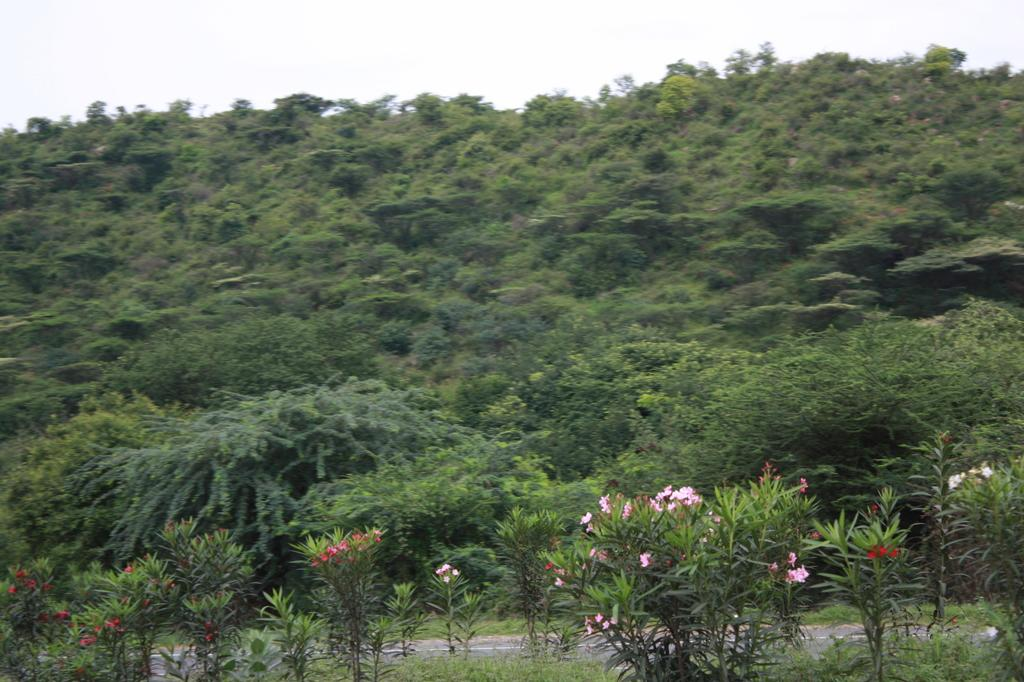What type of plants are featured in the image? There are plants with flowers in the image. What colors are the flowers? The flowers are in pink and red colors. What can be seen in the background of the image? There are many trees in the background of the image. What is the color of the sky in the image? The sky is white in the image. What type of quince is being served at the party in the image? There is no party or quince present in the image; it features plants with flowers and a white sky. What songs are being sung by the people in the image? There are no people or songs present in the image; it only shows plants with flowers, trees in the background, and a white sky. 